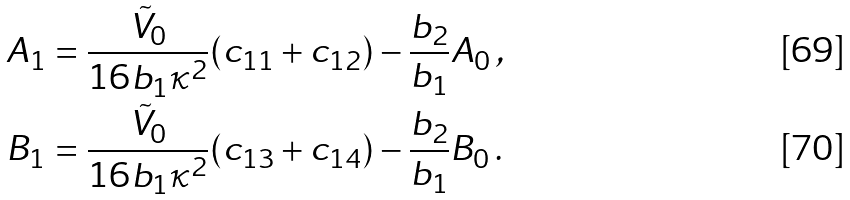<formula> <loc_0><loc_0><loc_500><loc_500>A _ { 1 } & = \frac { \tilde { V } _ { 0 } } { 1 6 b _ { 1 } \kappa ^ { 2 } } ( c _ { 1 1 } + c _ { 1 2 } ) - \frac { b _ { 2 } } { b _ { 1 } } A _ { 0 } \, , \\ B _ { 1 } & = \frac { \tilde { V } _ { 0 } } { 1 6 b _ { 1 } \kappa ^ { 2 } } ( c _ { 1 3 } + c _ { 1 4 } ) - \frac { b _ { 2 } } { b _ { 1 } } B _ { 0 } \, .</formula> 